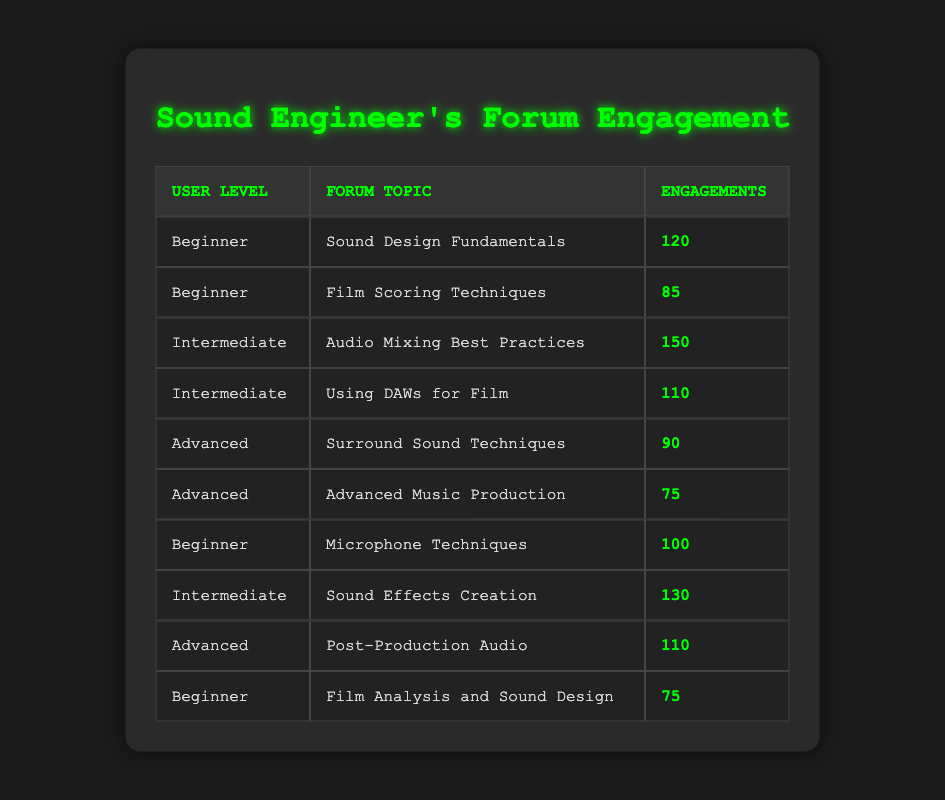What is the total number of engagements for Beginners? To find the total engagements for Beginners, we need to sum the engagements under the User Level "Beginner": 120 (Sound Design Fundamentals) + 85 (Film Scoring Techniques) + 100 (Microphone Techniques) + 75 (Film Analysis and Sound Design) = 380
Answer: 380 Which forum topic has the highest engagements from Intermediate users? Looking at the Intermediate user level, "Audio Mixing Best Practices" has 150 engagements, which is higher than "Using DAWs for Film" with 110 engagements. Therefore, it is the highest.
Answer: Audio Mixing Best Practices Is there a topic that has more engagements from Intermediate users than Advanced users? Yes, by checking the engagements, "Audio Mixing Best Practices" (150 from Intermediate) is greater than both "Surround Sound Techniques" (90) and "Advanced Music Production" (75) from Advanced users.
Answer: Yes What is the total number of engagements for Advanced users? For Advanced users, we sum: 90 (Surround Sound Techniques) + 75 (Advanced Music Production) + 110 (Post-Production Audio) = 275 engagements in total.
Answer: 275 What is the average engagement for both Intermediate and Advanced users? First, we find the total for Intermediate: 150 + 110 + 130 = 390. For Advanced: 90 + 75 + 110 = 275. Now, the average engagement for Intermediate users is 390/3 = 130. For Advanced users, it's 275/3 = 91.67, approximately.
Answer: Intermediate: 130, Advanced: 91.67 Is the total engagement count for Sound Effects Creation greater than for Sound Design Fundamentals? Yes, Sound Effects Creation with 130 engagements is greater than Sound Design Fundamentals, which has 120 engagements.
Answer: Yes Which user level has the least total engagements? To determine this, we compute the total engagements for each user level: Beginners: 380, Intermediate: 390, Advanced: 275. The least engagement is for Advanced users at 275.
Answer: Advanced How many more engagements does the Intermediate level have compared to Beginners? Subtract total engagements for Beginners (380) from Intermediate (390): 390 - 380 = 10 more engagements.
Answer: 10 What is the ratio of engagements for the topic "Sound Design Fundamentals" to "Film Analysis and Sound Design"? The engagements for "Sound Design Fundamentals" is 120, and for "Film Analysis and Sound Design" is 75. The ratio is 120:75, which can be simplified to 8:5.
Answer: 8:5 